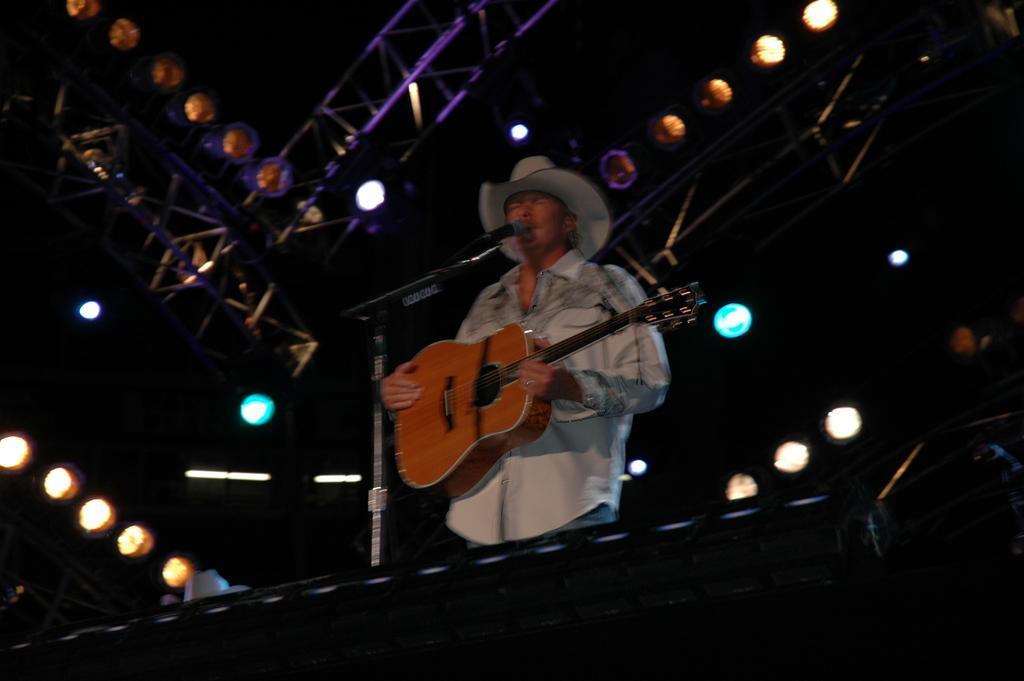Could you give a brief overview of what you see in this image? As we can see in the image there are lights, a man holding guitar and in front of him there is a mic. 